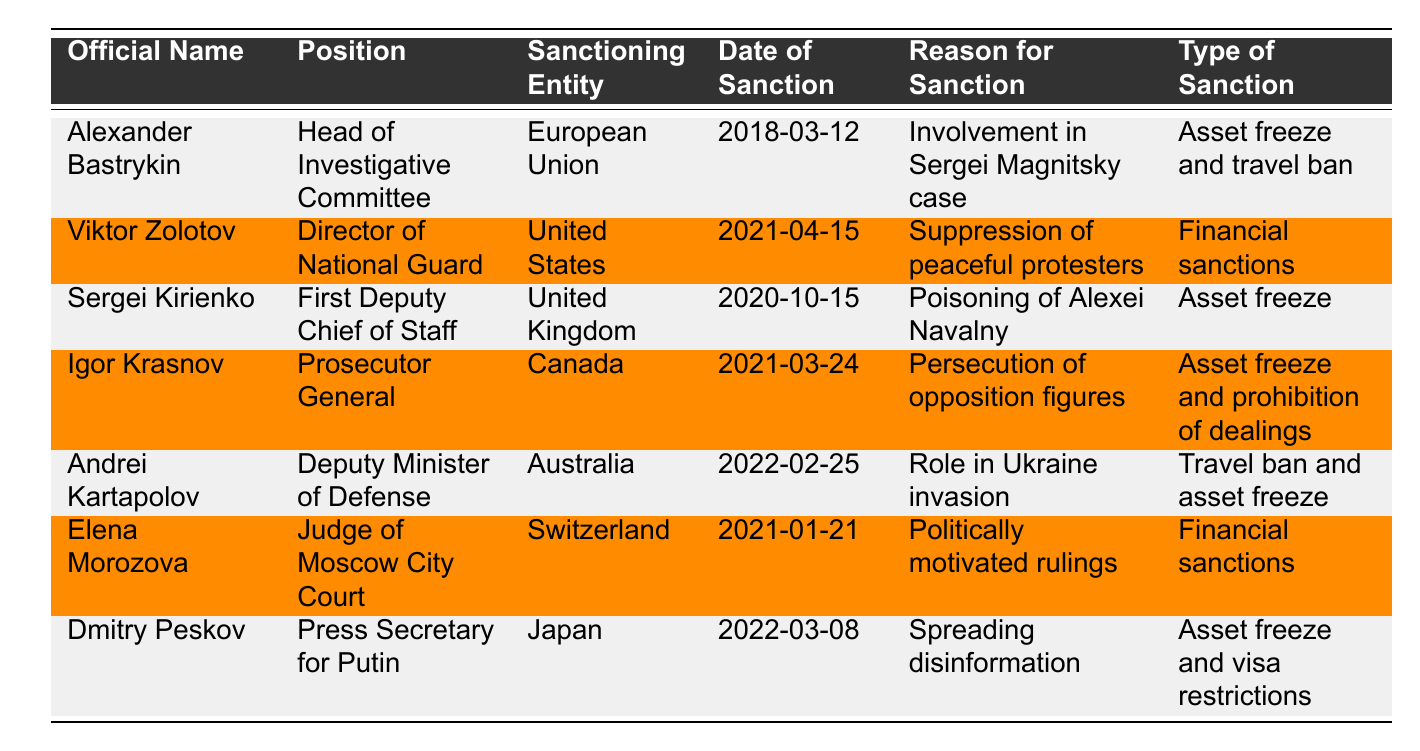What is the position of Alexander Bastrykin? The table lists Alexander Bastrykin as the "Head of Investigative Committee" under the Position column.
Answer: Head of Investigative Committee Which official was sanctioned by the European Union? The table indicates that Alexander Bastrykin was sanctioned by the European Union.
Answer: Alexander Bastrykin What type of sanctions were imposed on Viktor Zolotov? Referring to the table, it shows that Viktor Zolotov faced financial sanctions.
Answer: Financial sanctions How many officials have been sanctioned by the United States? Looking at the table, Viktor Zolotov is the only official listed under sanctions by the United States.
Answer: 1 What was the reason for the sanction against Sergei Kirienko? The table states that Sergei Kirienko was sanctioned due to his involvement in the poisoning of Alexei Navalny.
Answer: Poisoning of Alexei Navalny Which country sanctioned Elena Morozova, and what was the reason? The table indicates that Switzerland sanctioned Elena Morozova for politically motivated rulings.
Answer: Switzerland; Politically motivated rulings Is there an official who has been sanctioned for spreading disinformation? Yes, the table shows that Dmitry Peskov was sanctioned for spreading disinformation.
Answer: Yes Who faced sanctions related to the role in the Ukraine invasion? According to the table, Andrei Kartapolov faced sanctions related to his role in the invasion of Ukraine.
Answer: Andrei Kartapolov What is the collective type of sanctions applied to Igor Krasnov? The table lists that Igor Krasnov faced asset freeze and prohibition of dealings as his sanctions.
Answer: Asset freeze and prohibition of dealings Which sanctioning entity imposed asset freeze and travel ban together? The table shows that the European Union imposed asset freeze and travel ban on Alexander Bastrykin.
Answer: European Union How many officials are associated with asset freeze sanctions? Referring to the table, there are four officials: Alexander Bastrykin, Sergei Kirienko, Igor Krasnov, and Dmitry Peskov who have asset freeze sanctions.
Answer: 4 What position does the official sanctioned by Japan hold? The table indicates that the official sanctioned by Japan is Dmitry Peskov, who is the Press Secretary for Putin.
Answer: Press Secretary for Putin Which official was sanctioned on 2022-03-08? The table specifies that on 2022-03-08, Dmitry Peskov was sanctioned.
Answer: Dmitry Peskov If we only consider asset freezes, how many officials were sanctioned? The data shows there are four officials: Alexander Bastrykin, Sergei Kirienko, Igor Krasnov, and Dmitry Peskov.
Answer: 4 Who among the sanctioned officials has the title of Deputy Minister of Defense? The table reveals that Andrei Kartapolov holds the title of Deputy Minister of Defense.
Answer: Andrei Kartapolov What is the relationship between Viktor Zolotov and the suppression of peaceful protesters? According to the table, Viktor Zolotov was sanctioned specifically for his role in suppressing peaceful protesters.
Answer: He was sanctioned for suppressing peaceful protesters 